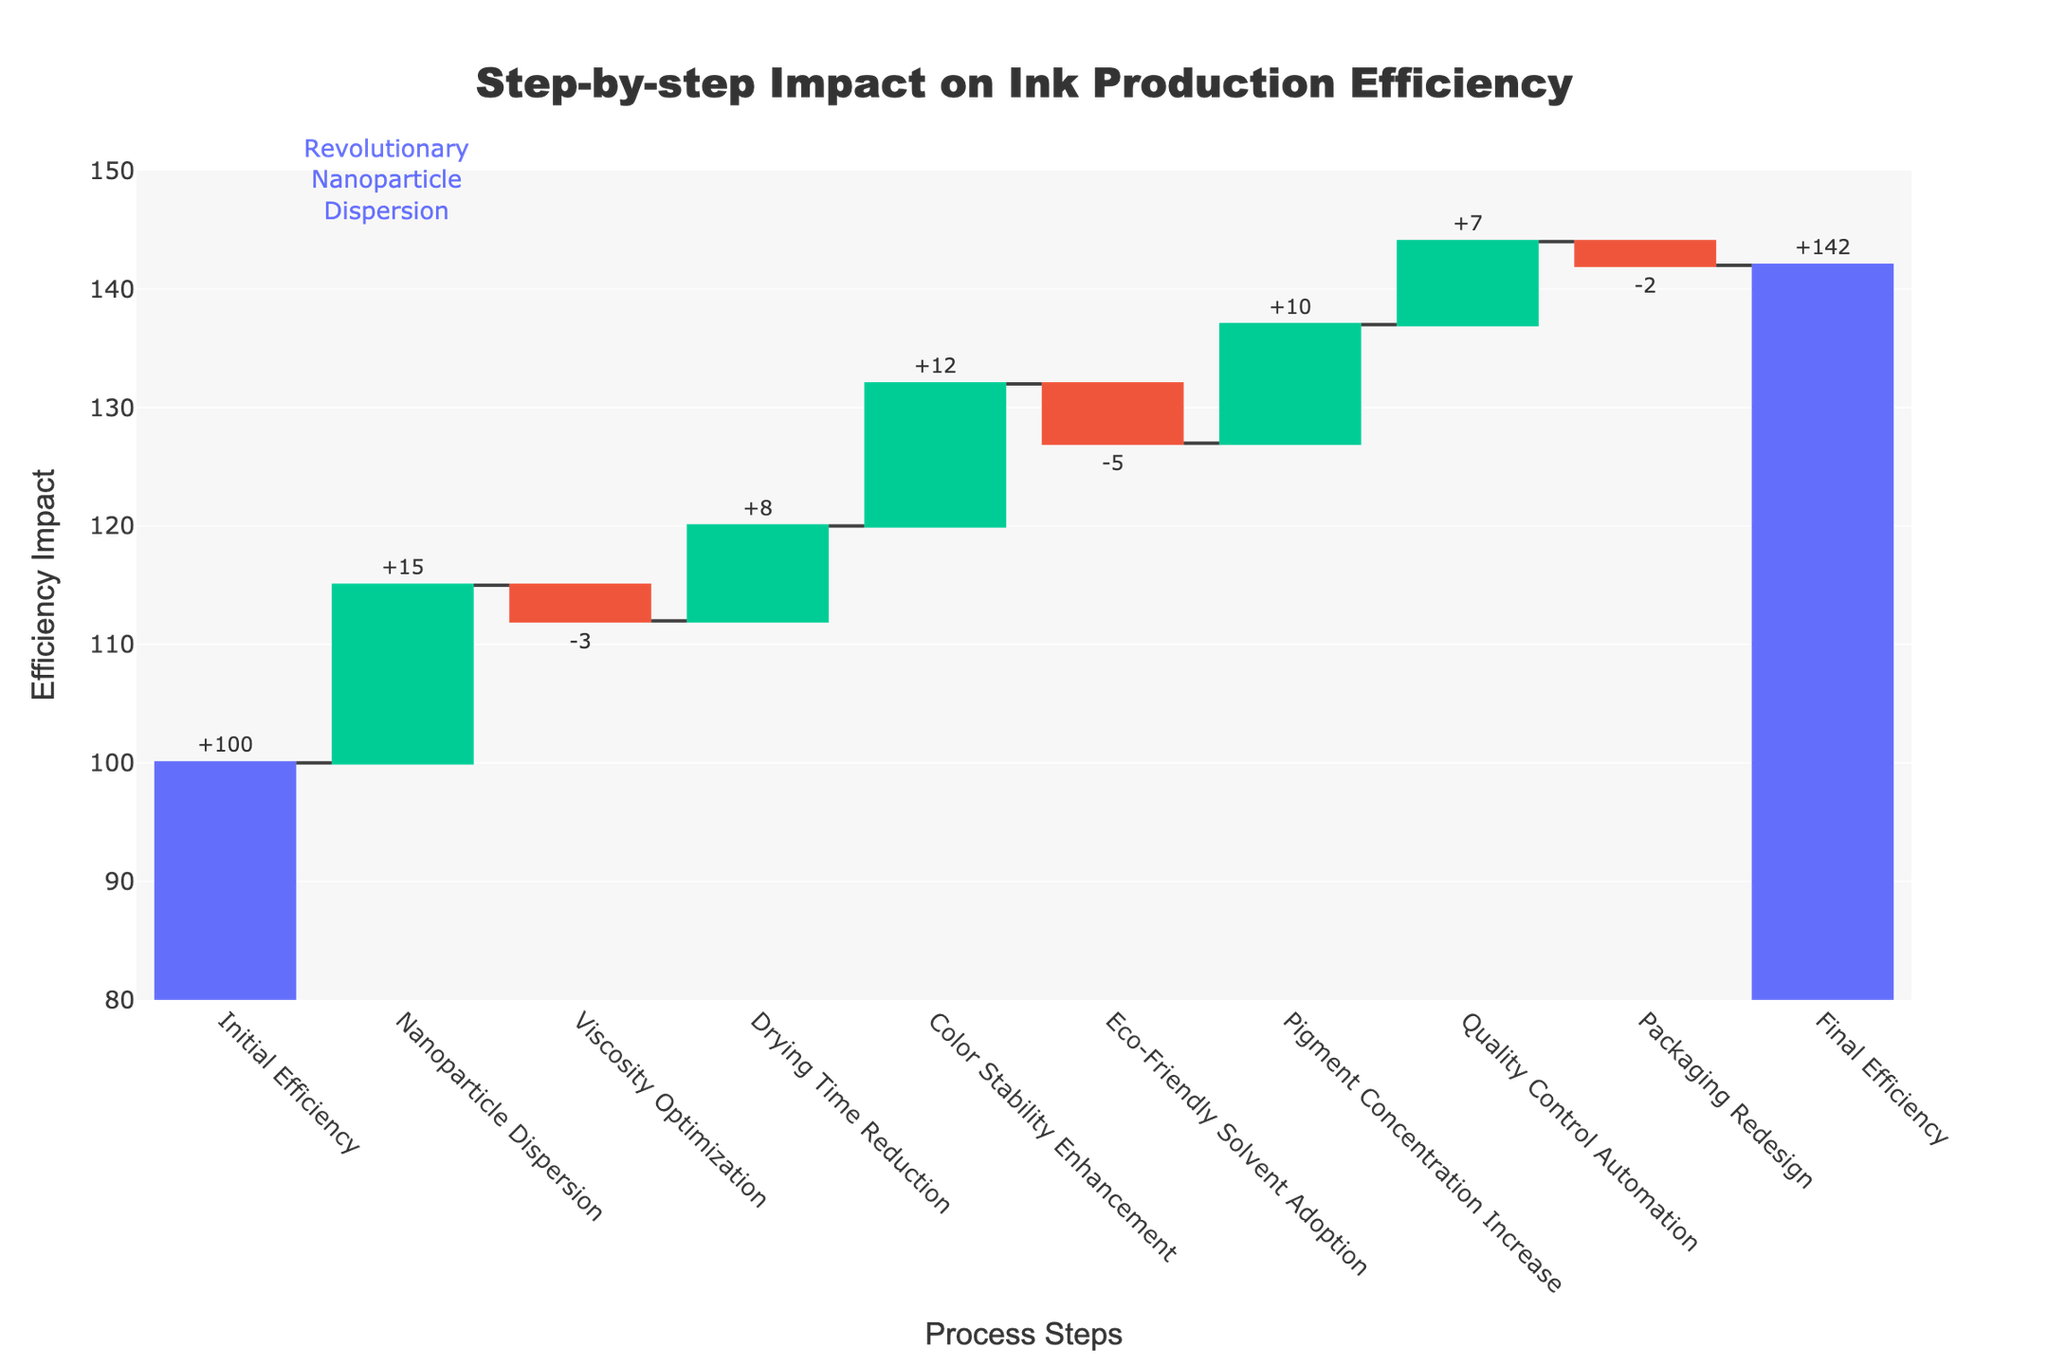What is the initial production efficiency percentage? The initial production efficiency is given directly in the figure as "Initial Efficiency" with a value of 100.
Answer: 100 How much does nanoparticle dispersion contribute to the efficiency? According to the chart, the nanoparticle dispersion step adds +15 to the efficiency.
Answer: +15 What is the impact of viscosity optimization on efficiency? The step titled "Viscosity Optimization" shows a -3 impact on efficiency.
Answer: -3 Which step has the highest positive impact on production efficiency? By looking at the heights of the bars with positive impacts, "Color Stability Enhancement" has the highest positive impact with +12.
Answer: Color Stability Enhancement, +12 What is the total efficiency impact after implementing quality control automation? Starting from the initial efficiency of 100 and adding the efficiencies step-by-step up to Quality Control Automation (+7), we can see the accumulative impact: 100 + 15 - 3 + 8 + 12 - 5 + 10 + 7 = 144. The efficiency at this step is 144.
Answer: 144 What effect does adopting eco-friendly solvents have on the efficiency? The step "Eco-Friendly Solvent Adoption" shows a reduction in efficiency by -5.
Answer: -5 What is the final production efficiency after all the improvements? The figure clearly states the "Final Efficiency" as 142 after all the steps.
Answer: 142 Which process step decreased the efficiency the most? "Viscosity Optimization" has the highest negative impact with -3, but "Eco-Friendly Solvent Adoption" decreased it further to -5. Therefore, it has the highest negative impact.
Answer: Eco-Friendly Solvent Adoption, -5 How much does the packaging redesign affect efficiency? The packaging redesign step indicates a -2 impact on the efficiency.
Answer: -2 What is the net change in efficiency from the beginning to the end of the process? To find the net change, we take the final efficiency 142 and subtract the initial efficiency 100: 142 - 100.
Answer: +42 